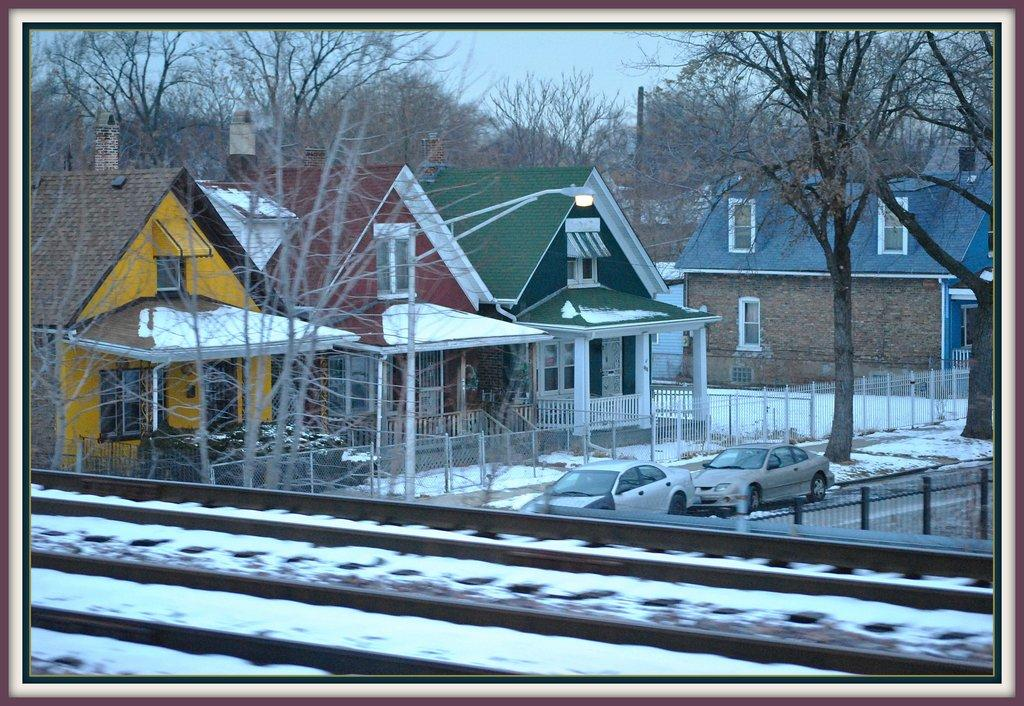What type of structures can be seen in the image? There are houses in the image. What surrounds the houses? There are trees around the houses. What vehicles are present in the image? There are cars in the image. What weather condition is depicted in the image? There is snow visible in the image. What type of transportation infrastructure is present in the image? There is a train track in the image. Can you describe the argument between the tiger and the oil in the image? There is no tiger or oil present in the image, so there is no argument to describe. 